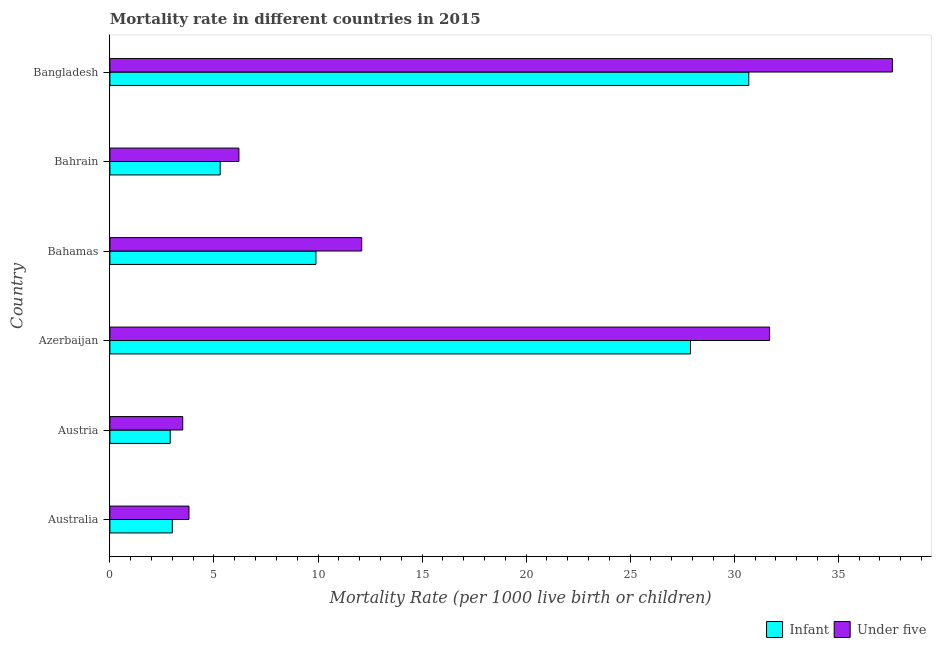Are the number of bars per tick equal to the number of legend labels?
Your response must be concise. Yes. Are the number of bars on each tick of the Y-axis equal?
Your response must be concise. Yes. What is the label of the 2nd group of bars from the top?
Keep it short and to the point. Bahrain. What is the under-5 mortality rate in Bangladesh?
Offer a very short reply. 37.6. Across all countries, what is the maximum infant mortality rate?
Offer a very short reply. 30.7. In which country was the infant mortality rate minimum?
Offer a very short reply. Austria. What is the total under-5 mortality rate in the graph?
Your answer should be compact. 94.9. What is the difference between the infant mortality rate in Azerbaijan and that in Bahrain?
Give a very brief answer. 22.6. What is the difference between the under-5 mortality rate in Australia and the infant mortality rate in Bahrain?
Your response must be concise. -1.5. What is the average infant mortality rate per country?
Ensure brevity in your answer.  13.28. What is the difference between the infant mortality rate and under-5 mortality rate in Bahamas?
Your response must be concise. -2.2. What is the ratio of the under-5 mortality rate in Australia to that in Bahamas?
Your response must be concise. 0.31. Is the difference between the infant mortality rate in Australia and Bangladesh greater than the difference between the under-5 mortality rate in Australia and Bangladesh?
Provide a short and direct response. Yes. What is the difference between the highest and the second highest under-5 mortality rate?
Your answer should be very brief. 5.9. What is the difference between the highest and the lowest infant mortality rate?
Provide a short and direct response. 27.8. In how many countries, is the under-5 mortality rate greater than the average under-5 mortality rate taken over all countries?
Offer a terse response. 2. Is the sum of the infant mortality rate in Australia and Azerbaijan greater than the maximum under-5 mortality rate across all countries?
Ensure brevity in your answer.  No. What does the 1st bar from the top in Australia represents?
Your answer should be very brief. Under five. What does the 2nd bar from the bottom in Bahrain represents?
Offer a terse response. Under five. How many bars are there?
Provide a short and direct response. 12. How many countries are there in the graph?
Offer a terse response. 6. Are the values on the major ticks of X-axis written in scientific E-notation?
Ensure brevity in your answer.  No. Does the graph contain grids?
Provide a succinct answer. No. Where does the legend appear in the graph?
Make the answer very short. Bottom right. How are the legend labels stacked?
Your answer should be compact. Horizontal. What is the title of the graph?
Provide a succinct answer. Mortality rate in different countries in 2015. What is the label or title of the X-axis?
Keep it short and to the point. Mortality Rate (per 1000 live birth or children). What is the Mortality Rate (per 1000 live birth or children) of Infant in Australia?
Make the answer very short. 3. What is the Mortality Rate (per 1000 live birth or children) in Infant in Azerbaijan?
Provide a succinct answer. 27.9. What is the Mortality Rate (per 1000 live birth or children) in Under five in Azerbaijan?
Keep it short and to the point. 31.7. What is the Mortality Rate (per 1000 live birth or children) in Infant in Bahamas?
Provide a succinct answer. 9.9. What is the Mortality Rate (per 1000 live birth or children) of Under five in Bahamas?
Provide a succinct answer. 12.1. What is the Mortality Rate (per 1000 live birth or children) of Under five in Bahrain?
Provide a short and direct response. 6.2. What is the Mortality Rate (per 1000 live birth or children) in Infant in Bangladesh?
Your response must be concise. 30.7. What is the Mortality Rate (per 1000 live birth or children) in Under five in Bangladesh?
Your answer should be very brief. 37.6. Across all countries, what is the maximum Mortality Rate (per 1000 live birth or children) of Infant?
Ensure brevity in your answer.  30.7. Across all countries, what is the maximum Mortality Rate (per 1000 live birth or children) of Under five?
Provide a succinct answer. 37.6. Across all countries, what is the minimum Mortality Rate (per 1000 live birth or children) of Under five?
Your answer should be very brief. 3.5. What is the total Mortality Rate (per 1000 live birth or children) in Infant in the graph?
Make the answer very short. 79.7. What is the total Mortality Rate (per 1000 live birth or children) in Under five in the graph?
Provide a succinct answer. 94.9. What is the difference between the Mortality Rate (per 1000 live birth or children) in Infant in Australia and that in Austria?
Ensure brevity in your answer.  0.1. What is the difference between the Mortality Rate (per 1000 live birth or children) in Under five in Australia and that in Austria?
Offer a very short reply. 0.3. What is the difference between the Mortality Rate (per 1000 live birth or children) of Infant in Australia and that in Azerbaijan?
Make the answer very short. -24.9. What is the difference between the Mortality Rate (per 1000 live birth or children) in Under five in Australia and that in Azerbaijan?
Ensure brevity in your answer.  -27.9. What is the difference between the Mortality Rate (per 1000 live birth or children) of Under five in Australia and that in Bahamas?
Your answer should be compact. -8.3. What is the difference between the Mortality Rate (per 1000 live birth or children) in Under five in Australia and that in Bahrain?
Offer a very short reply. -2.4. What is the difference between the Mortality Rate (per 1000 live birth or children) of Infant in Australia and that in Bangladesh?
Provide a short and direct response. -27.7. What is the difference between the Mortality Rate (per 1000 live birth or children) in Under five in Australia and that in Bangladesh?
Your answer should be very brief. -33.8. What is the difference between the Mortality Rate (per 1000 live birth or children) of Under five in Austria and that in Azerbaijan?
Your response must be concise. -28.2. What is the difference between the Mortality Rate (per 1000 live birth or children) in Under five in Austria and that in Bahamas?
Provide a succinct answer. -8.6. What is the difference between the Mortality Rate (per 1000 live birth or children) of Under five in Austria and that in Bahrain?
Provide a succinct answer. -2.7. What is the difference between the Mortality Rate (per 1000 live birth or children) of Infant in Austria and that in Bangladesh?
Give a very brief answer. -27.8. What is the difference between the Mortality Rate (per 1000 live birth or children) in Under five in Austria and that in Bangladesh?
Provide a succinct answer. -34.1. What is the difference between the Mortality Rate (per 1000 live birth or children) in Under five in Azerbaijan and that in Bahamas?
Your answer should be compact. 19.6. What is the difference between the Mortality Rate (per 1000 live birth or children) of Infant in Azerbaijan and that in Bahrain?
Offer a very short reply. 22.6. What is the difference between the Mortality Rate (per 1000 live birth or children) of Infant in Azerbaijan and that in Bangladesh?
Provide a succinct answer. -2.8. What is the difference between the Mortality Rate (per 1000 live birth or children) in Infant in Bahamas and that in Bahrain?
Your answer should be very brief. 4.6. What is the difference between the Mortality Rate (per 1000 live birth or children) in Infant in Bahamas and that in Bangladesh?
Offer a terse response. -20.8. What is the difference between the Mortality Rate (per 1000 live birth or children) in Under five in Bahamas and that in Bangladesh?
Provide a succinct answer. -25.5. What is the difference between the Mortality Rate (per 1000 live birth or children) in Infant in Bahrain and that in Bangladesh?
Your answer should be very brief. -25.4. What is the difference between the Mortality Rate (per 1000 live birth or children) in Under five in Bahrain and that in Bangladesh?
Ensure brevity in your answer.  -31.4. What is the difference between the Mortality Rate (per 1000 live birth or children) of Infant in Australia and the Mortality Rate (per 1000 live birth or children) of Under five in Austria?
Your answer should be very brief. -0.5. What is the difference between the Mortality Rate (per 1000 live birth or children) in Infant in Australia and the Mortality Rate (per 1000 live birth or children) in Under five in Azerbaijan?
Your response must be concise. -28.7. What is the difference between the Mortality Rate (per 1000 live birth or children) of Infant in Australia and the Mortality Rate (per 1000 live birth or children) of Under five in Bangladesh?
Provide a short and direct response. -34.6. What is the difference between the Mortality Rate (per 1000 live birth or children) in Infant in Austria and the Mortality Rate (per 1000 live birth or children) in Under five in Azerbaijan?
Offer a terse response. -28.8. What is the difference between the Mortality Rate (per 1000 live birth or children) of Infant in Austria and the Mortality Rate (per 1000 live birth or children) of Under five in Bangladesh?
Ensure brevity in your answer.  -34.7. What is the difference between the Mortality Rate (per 1000 live birth or children) of Infant in Azerbaijan and the Mortality Rate (per 1000 live birth or children) of Under five in Bahrain?
Your response must be concise. 21.7. What is the difference between the Mortality Rate (per 1000 live birth or children) in Infant in Azerbaijan and the Mortality Rate (per 1000 live birth or children) in Under five in Bangladesh?
Your answer should be very brief. -9.7. What is the difference between the Mortality Rate (per 1000 live birth or children) in Infant in Bahamas and the Mortality Rate (per 1000 live birth or children) in Under five in Bahrain?
Keep it short and to the point. 3.7. What is the difference between the Mortality Rate (per 1000 live birth or children) in Infant in Bahamas and the Mortality Rate (per 1000 live birth or children) in Under five in Bangladesh?
Provide a succinct answer. -27.7. What is the difference between the Mortality Rate (per 1000 live birth or children) of Infant in Bahrain and the Mortality Rate (per 1000 live birth or children) of Under five in Bangladesh?
Provide a succinct answer. -32.3. What is the average Mortality Rate (per 1000 live birth or children) in Infant per country?
Ensure brevity in your answer.  13.28. What is the average Mortality Rate (per 1000 live birth or children) in Under five per country?
Offer a very short reply. 15.82. What is the difference between the Mortality Rate (per 1000 live birth or children) of Infant and Mortality Rate (per 1000 live birth or children) of Under five in Australia?
Ensure brevity in your answer.  -0.8. What is the difference between the Mortality Rate (per 1000 live birth or children) of Infant and Mortality Rate (per 1000 live birth or children) of Under five in Austria?
Your answer should be very brief. -0.6. What is the ratio of the Mortality Rate (per 1000 live birth or children) of Infant in Australia to that in Austria?
Give a very brief answer. 1.03. What is the ratio of the Mortality Rate (per 1000 live birth or children) in Under five in Australia to that in Austria?
Provide a succinct answer. 1.09. What is the ratio of the Mortality Rate (per 1000 live birth or children) in Infant in Australia to that in Azerbaijan?
Your answer should be very brief. 0.11. What is the ratio of the Mortality Rate (per 1000 live birth or children) of Under five in Australia to that in Azerbaijan?
Make the answer very short. 0.12. What is the ratio of the Mortality Rate (per 1000 live birth or children) of Infant in Australia to that in Bahamas?
Ensure brevity in your answer.  0.3. What is the ratio of the Mortality Rate (per 1000 live birth or children) of Under five in Australia to that in Bahamas?
Give a very brief answer. 0.31. What is the ratio of the Mortality Rate (per 1000 live birth or children) in Infant in Australia to that in Bahrain?
Your answer should be very brief. 0.57. What is the ratio of the Mortality Rate (per 1000 live birth or children) of Under five in Australia to that in Bahrain?
Your answer should be very brief. 0.61. What is the ratio of the Mortality Rate (per 1000 live birth or children) in Infant in Australia to that in Bangladesh?
Your answer should be very brief. 0.1. What is the ratio of the Mortality Rate (per 1000 live birth or children) of Under five in Australia to that in Bangladesh?
Provide a short and direct response. 0.1. What is the ratio of the Mortality Rate (per 1000 live birth or children) in Infant in Austria to that in Azerbaijan?
Your answer should be compact. 0.1. What is the ratio of the Mortality Rate (per 1000 live birth or children) in Under five in Austria to that in Azerbaijan?
Provide a succinct answer. 0.11. What is the ratio of the Mortality Rate (per 1000 live birth or children) in Infant in Austria to that in Bahamas?
Keep it short and to the point. 0.29. What is the ratio of the Mortality Rate (per 1000 live birth or children) in Under five in Austria to that in Bahamas?
Your response must be concise. 0.29. What is the ratio of the Mortality Rate (per 1000 live birth or children) in Infant in Austria to that in Bahrain?
Keep it short and to the point. 0.55. What is the ratio of the Mortality Rate (per 1000 live birth or children) of Under five in Austria to that in Bahrain?
Offer a terse response. 0.56. What is the ratio of the Mortality Rate (per 1000 live birth or children) in Infant in Austria to that in Bangladesh?
Your response must be concise. 0.09. What is the ratio of the Mortality Rate (per 1000 live birth or children) in Under five in Austria to that in Bangladesh?
Your response must be concise. 0.09. What is the ratio of the Mortality Rate (per 1000 live birth or children) in Infant in Azerbaijan to that in Bahamas?
Your answer should be compact. 2.82. What is the ratio of the Mortality Rate (per 1000 live birth or children) in Under five in Azerbaijan to that in Bahamas?
Offer a terse response. 2.62. What is the ratio of the Mortality Rate (per 1000 live birth or children) of Infant in Azerbaijan to that in Bahrain?
Make the answer very short. 5.26. What is the ratio of the Mortality Rate (per 1000 live birth or children) in Under five in Azerbaijan to that in Bahrain?
Provide a succinct answer. 5.11. What is the ratio of the Mortality Rate (per 1000 live birth or children) in Infant in Azerbaijan to that in Bangladesh?
Keep it short and to the point. 0.91. What is the ratio of the Mortality Rate (per 1000 live birth or children) in Under five in Azerbaijan to that in Bangladesh?
Your answer should be compact. 0.84. What is the ratio of the Mortality Rate (per 1000 live birth or children) of Infant in Bahamas to that in Bahrain?
Your answer should be very brief. 1.87. What is the ratio of the Mortality Rate (per 1000 live birth or children) in Under five in Bahamas to that in Bahrain?
Provide a succinct answer. 1.95. What is the ratio of the Mortality Rate (per 1000 live birth or children) of Infant in Bahamas to that in Bangladesh?
Provide a succinct answer. 0.32. What is the ratio of the Mortality Rate (per 1000 live birth or children) of Under five in Bahamas to that in Bangladesh?
Your answer should be compact. 0.32. What is the ratio of the Mortality Rate (per 1000 live birth or children) in Infant in Bahrain to that in Bangladesh?
Provide a succinct answer. 0.17. What is the ratio of the Mortality Rate (per 1000 live birth or children) of Under five in Bahrain to that in Bangladesh?
Offer a very short reply. 0.16. What is the difference between the highest and the second highest Mortality Rate (per 1000 live birth or children) in Infant?
Ensure brevity in your answer.  2.8. What is the difference between the highest and the lowest Mortality Rate (per 1000 live birth or children) of Infant?
Offer a terse response. 27.8. What is the difference between the highest and the lowest Mortality Rate (per 1000 live birth or children) of Under five?
Keep it short and to the point. 34.1. 